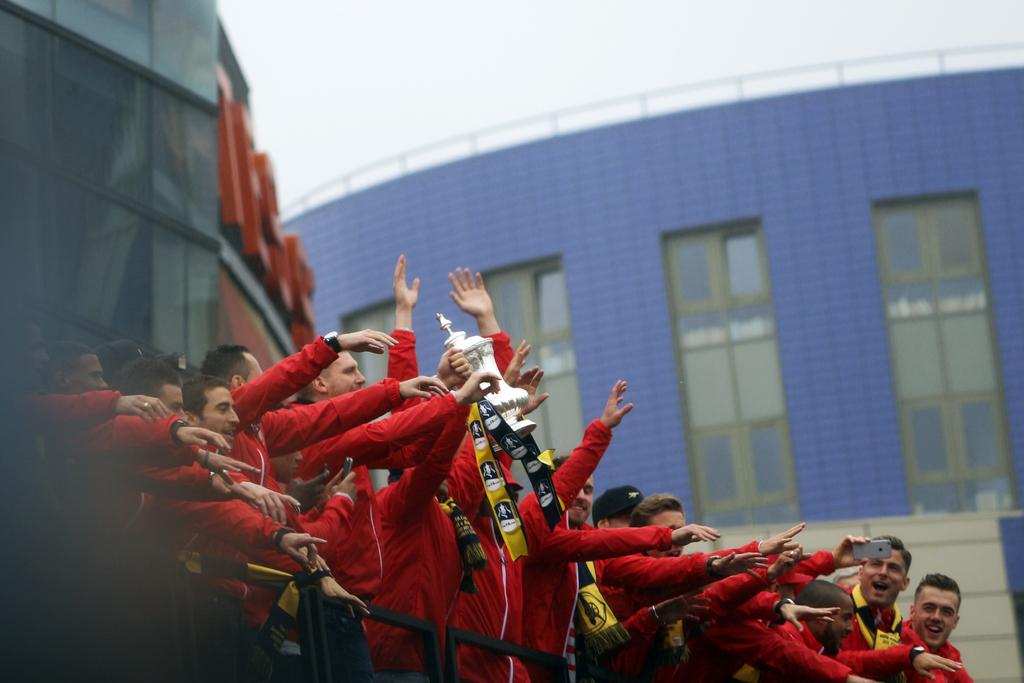Who or what is present in the image? There are people in the image. What are the people wearing? The people are wearing red dresses. What are the people holding in the image? The people are holding a trophy. What can be seen in the background of the image? There are buildings and windows visible in the background. What is the color of the sky in the image? The sky appears to be white in color. How many balloons are tied to the arm of the person in the image? There are no balloons present in the image. What type of yard can be seen in the image? There is no yard visible in the image. 